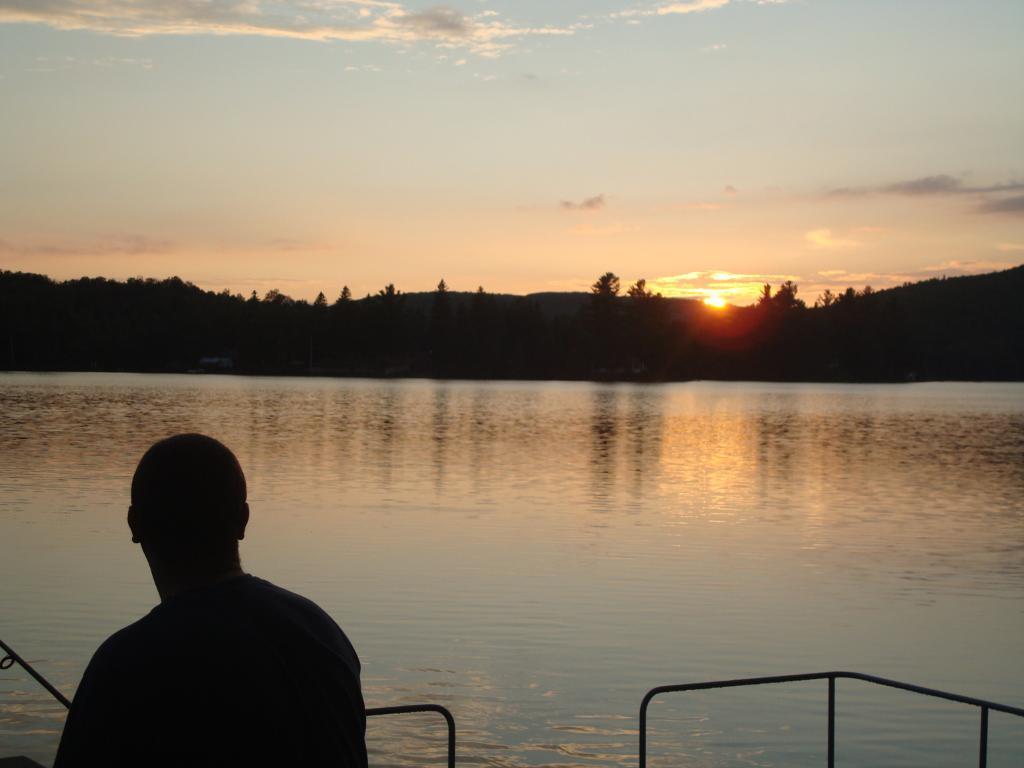Can you describe this image briefly? In this picture I can see a person and few rods in front. In the middle of this picture I can see the water. In the background I can see the trees, the sun and the sky. 